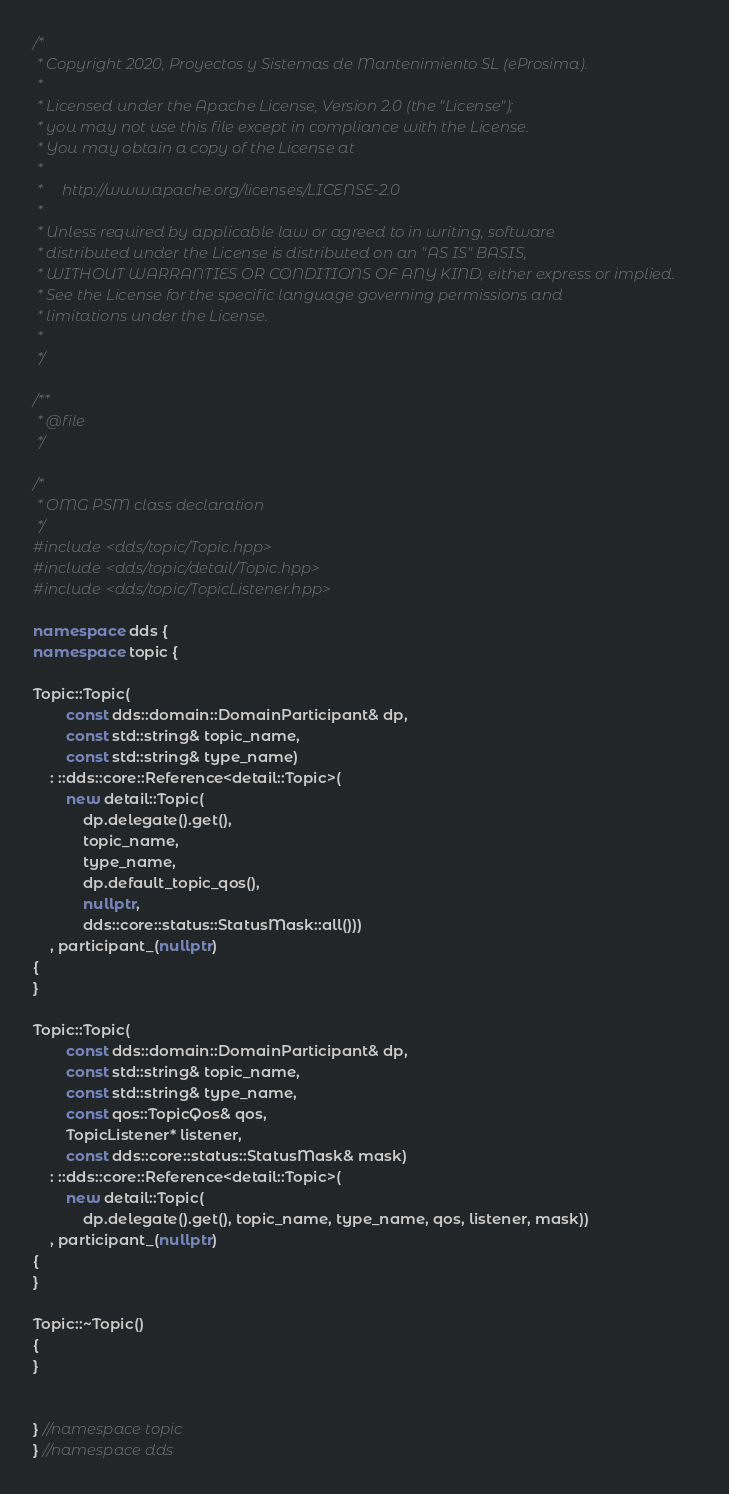Convert code to text. <code><loc_0><loc_0><loc_500><loc_500><_C++_>/*
 * Copyright 2020, Proyectos y Sistemas de Mantenimiento SL (eProsima).
 *
 * Licensed under the Apache License, Version 2.0 (the "License");
 * you may not use this file except in compliance with the License.
 * You may obtain a copy of the License at
 *
 *     http://www.apache.org/licenses/LICENSE-2.0
 *
 * Unless required by applicable law or agreed to in writing, software
 * distributed under the License is distributed on an "AS IS" BASIS,
 * WITHOUT WARRANTIES OR CONDITIONS OF ANY KIND, either express or implied.
 * See the License for the specific language governing permissions and
 * limitations under the License.
 *
 */

/**
 * @file
 */

/*
 * OMG PSM class declaration
 */
#include <dds/topic/Topic.hpp>
#include <dds/topic/detail/Topic.hpp>
#include <dds/topic/TopicListener.hpp>

namespace dds {
namespace topic {

Topic::Topic(
        const dds::domain::DomainParticipant& dp,
        const std::string& topic_name,
        const std::string& type_name)
    : ::dds::core::Reference<detail::Topic>(
        new detail::Topic(
            dp.delegate().get(),
            topic_name,
            type_name,
            dp.default_topic_qos(),
            nullptr,
            dds::core::status::StatusMask::all()))
    , participant_(nullptr)
{
}

Topic::Topic(
        const dds::domain::DomainParticipant& dp,
        const std::string& topic_name,
        const std::string& type_name,
        const qos::TopicQos& qos,
        TopicListener* listener,
        const dds::core::status::StatusMask& mask)
    : ::dds::core::Reference<detail::Topic>(
        new detail::Topic(
            dp.delegate().get(), topic_name, type_name, qos, listener, mask))
    , participant_(nullptr)
{
}

Topic::~Topic()
{
}


} //namespace topic
} //namespace dds

</code> 